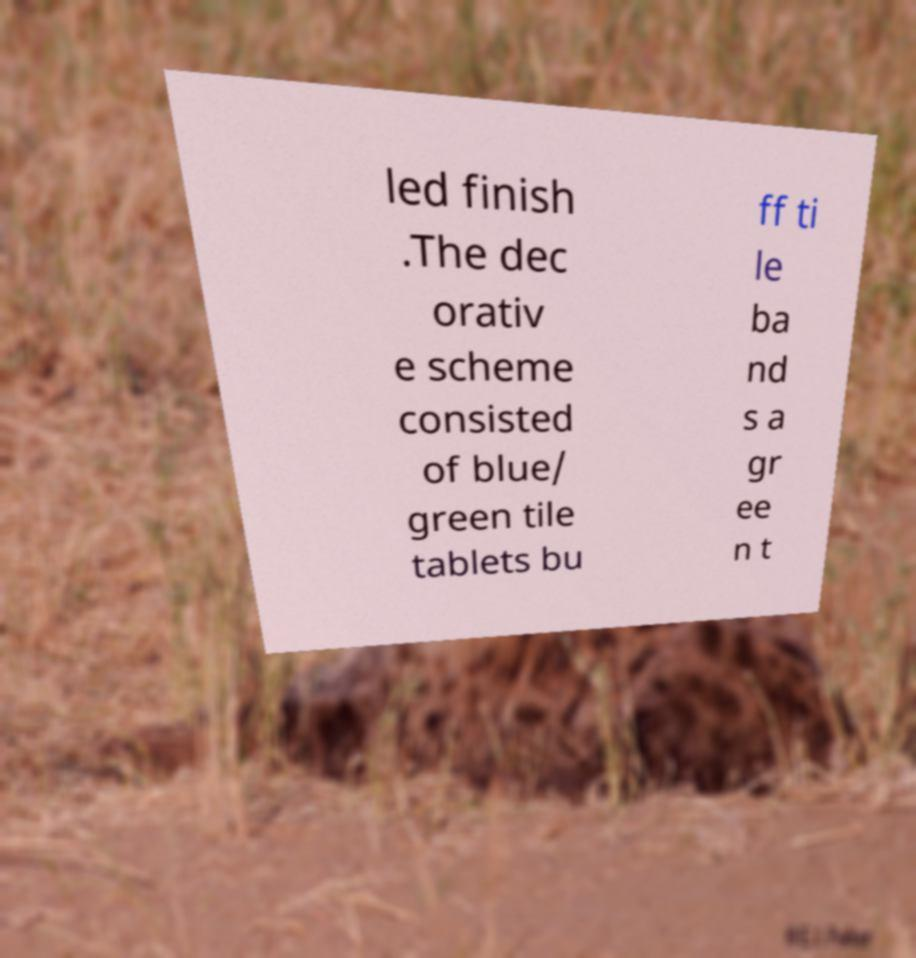For documentation purposes, I need the text within this image transcribed. Could you provide that? led finish .The dec orativ e scheme consisted of blue/ green tile tablets bu ff ti le ba nd s a gr ee n t 